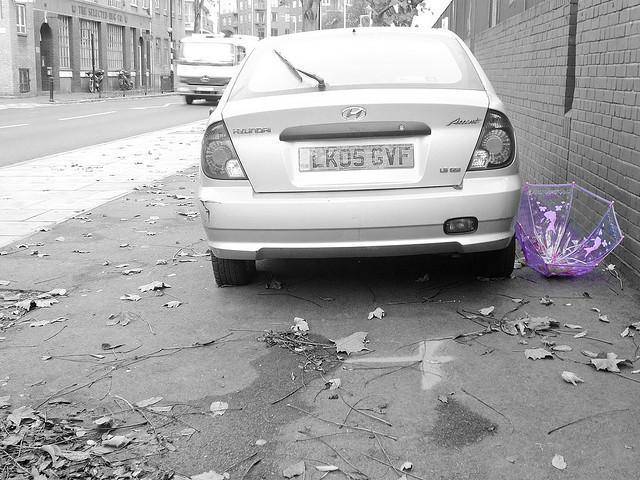What is this model of car called in South Korea?
Select the correct answer and articulate reasoning with the following format: 'Answer: answer
Rationale: rationale.'
Options: Hyundai verna, hyundai tucson, hyundai minho, hyundai kia. Answer: hyundai verna.
Rationale: The car is an accent which is a verna in south korea. 